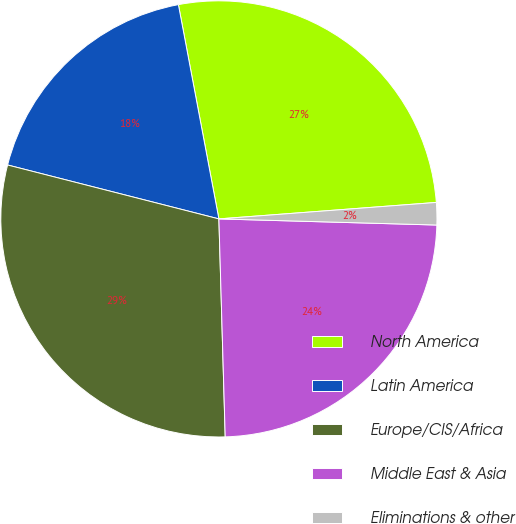Convert chart to OTSL. <chart><loc_0><loc_0><loc_500><loc_500><pie_chart><fcel>North America<fcel>Latin America<fcel>Europe/CIS/Africa<fcel>Middle East & Asia<fcel>Eliminations & other<nl><fcel>26.77%<fcel>18.05%<fcel>29.44%<fcel>24.09%<fcel>1.65%<nl></chart> 